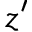Convert formula to latex. <formula><loc_0><loc_0><loc_500><loc_500>z ^ { \prime }</formula> 